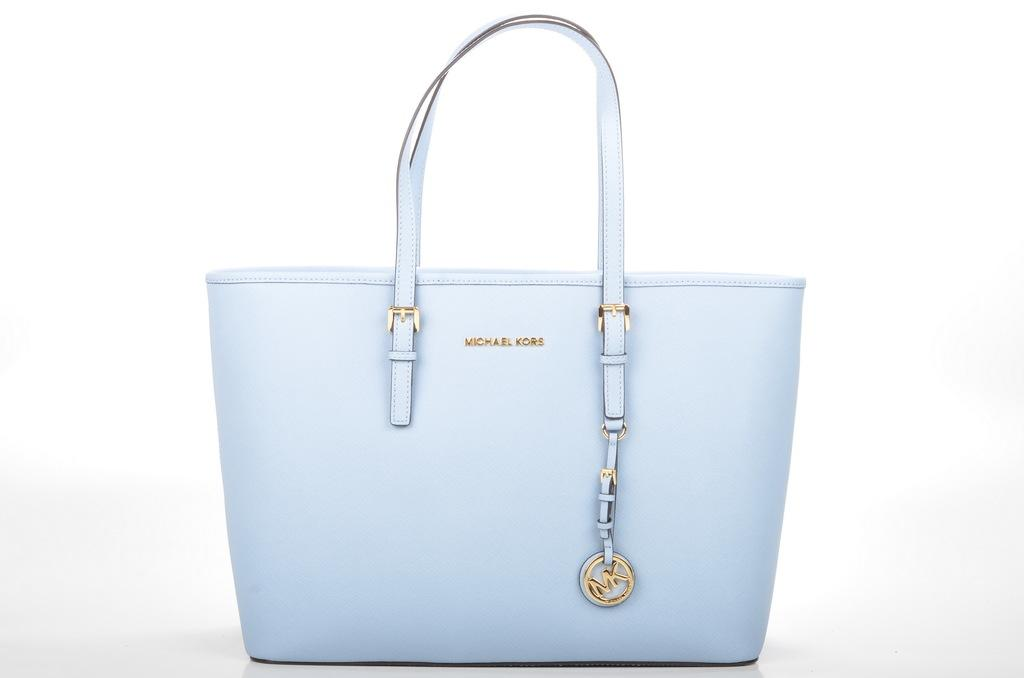What object can be seen in the image? There is a bag in the image. What is the color of the bag? The bag is white in color. How many chairs are present in the image? There is no mention of chairs in the provided facts, so it cannot be determined from the image. 